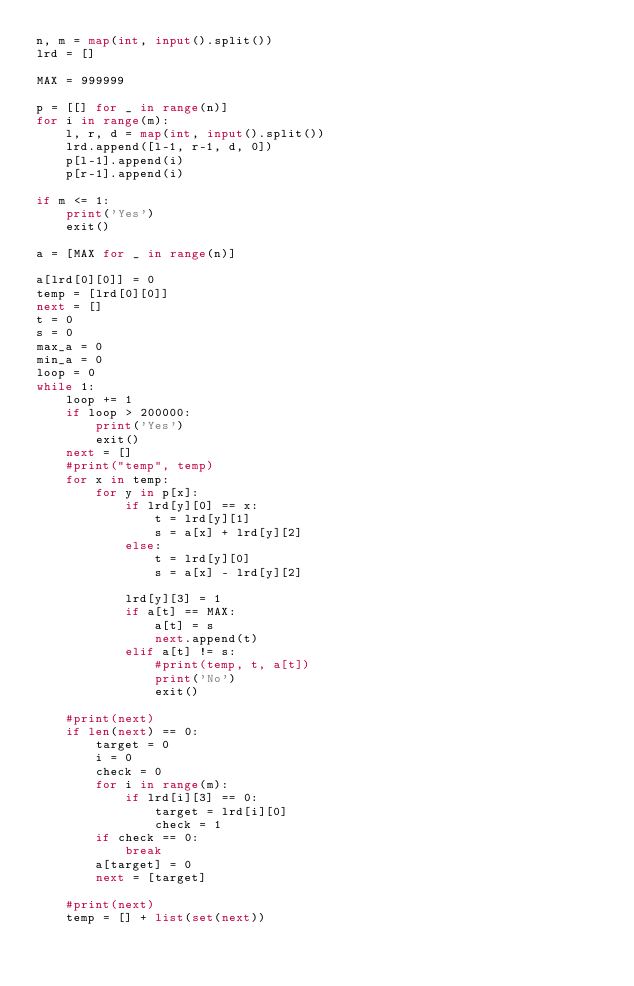Convert code to text. <code><loc_0><loc_0><loc_500><loc_500><_Python_>n, m = map(int, input().split())
lrd = []

MAX = 999999

p = [[] for _ in range(n)]
for i in range(m):
    l, r, d = map(int, input().split())
    lrd.append([l-1, r-1, d, 0])
    p[l-1].append(i)
    p[r-1].append(i)

if m <= 1:
    print('Yes')
    exit()

a = [MAX for _ in range(n)]

a[lrd[0][0]] = 0
temp = [lrd[0][0]]
next = []
t = 0
s = 0
max_a = 0
min_a = 0
loop = 0
while 1:
    loop += 1
    if loop > 200000:
        print('Yes')
        exit()
    next = []
    #print("temp", temp)
    for x in temp:
        for y in p[x]:
            if lrd[y][0] == x:
                t = lrd[y][1]
                s = a[x] + lrd[y][2]
            else:
                t = lrd[y][0]
                s = a[x] - lrd[y][2]

            lrd[y][3] = 1
            if a[t] == MAX:
                a[t] = s
                next.append(t)
            elif a[t] != s:
                #print(temp, t, a[t])
                print('No')
                exit()

    #print(next)
    if len(next) == 0:
        target = 0
        i = 0
        check = 0
        for i in range(m):
            if lrd[i][3] == 0:
                target = lrd[i][0]
                check = 1
        if check == 0:
            break
        a[target] = 0
        next = [target]

    #print(next)
    temp = [] + list(set(next))


</code> 